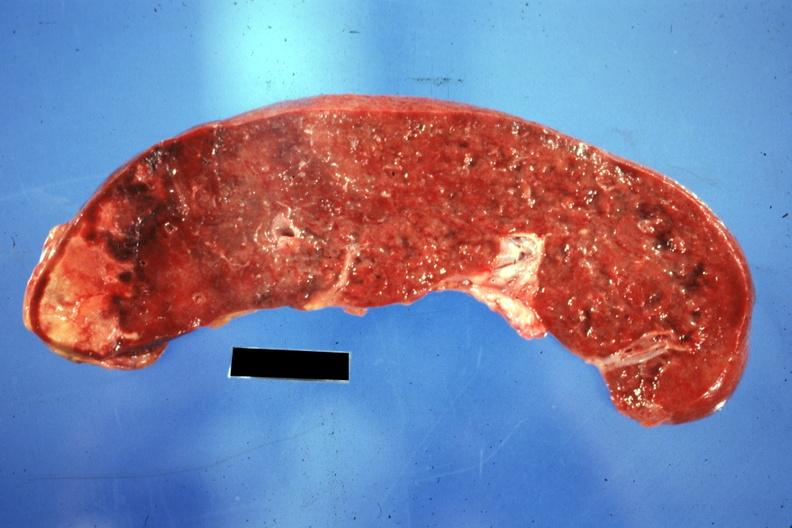s hematologic present?
Answer the question using a single word or phrase. Yes 